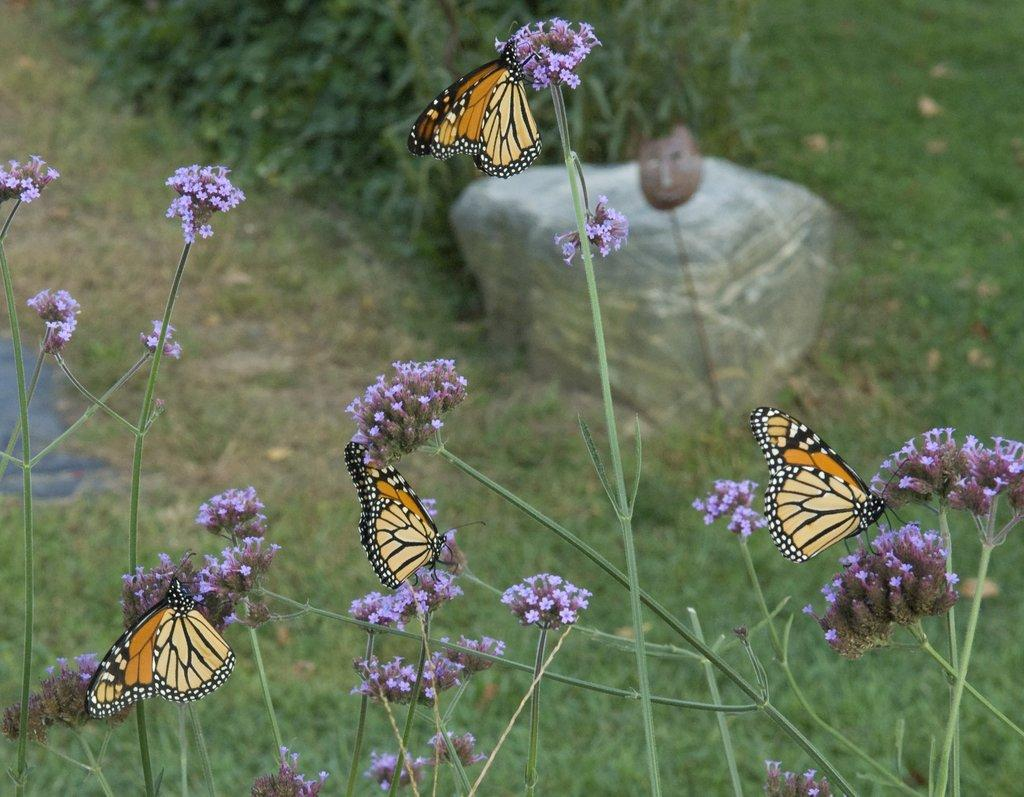What type of vegetation is present in the image? There is grass with flowers in the image. What can be seen on the flowers? There are butterflies on the flowers. What is visible on the ground behind the flowers? There is grass visible on the ground behind the flowers. What type of object is present in the image? There is a stone in the image. What type of feeling does the milk in the image evoke? There is no milk present in the image, so it cannot evoke any feelings. 